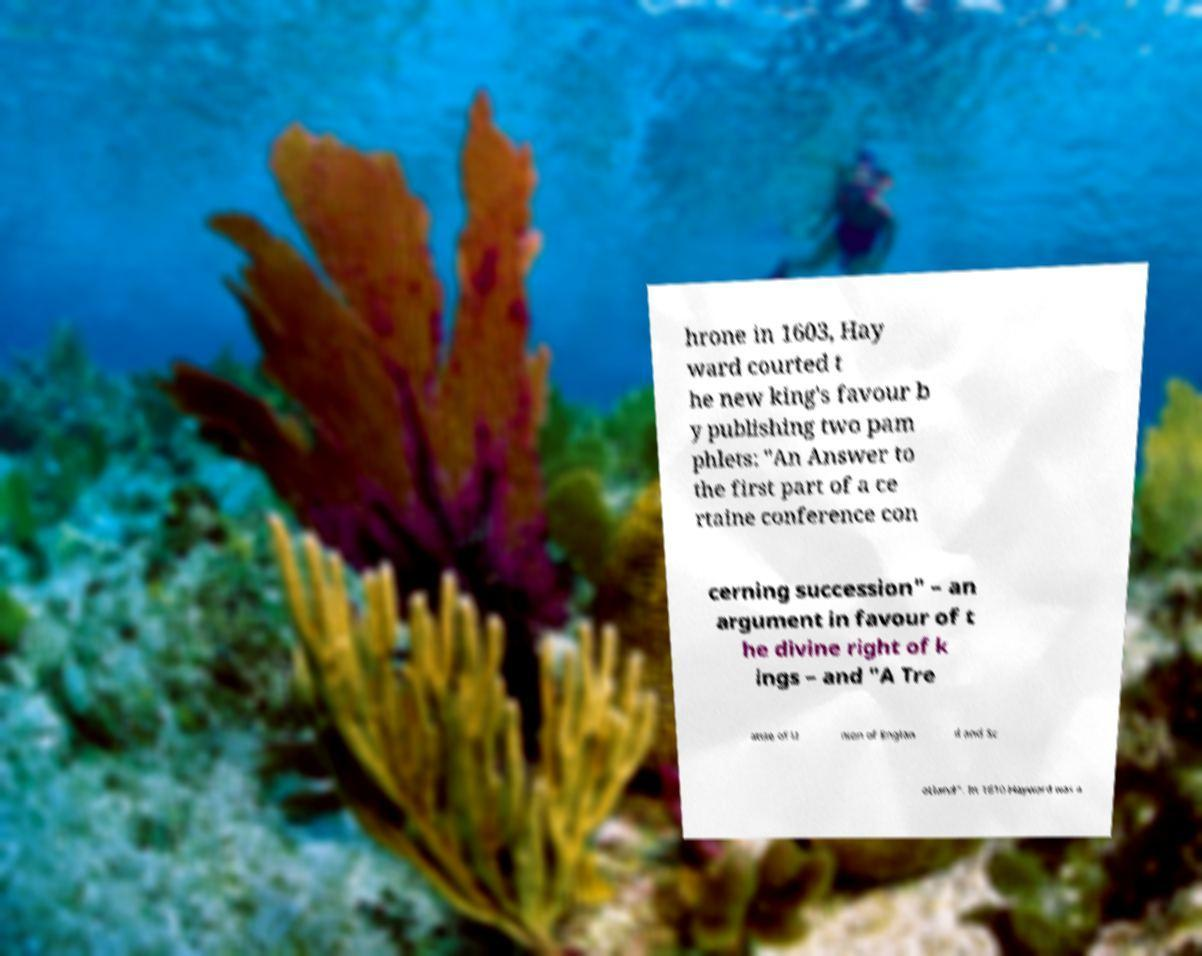Could you assist in decoding the text presented in this image and type it out clearly? hrone in 1603, Hay ward courted t he new king's favour b y publishing two pam phlets: "An Answer to the first part of a ce rtaine conference con cerning succession" – an argument in favour of t he divine right of k ings – and "A Tre atise of U nion of Englan d and Sc otland". In 1610 Hayward was a 